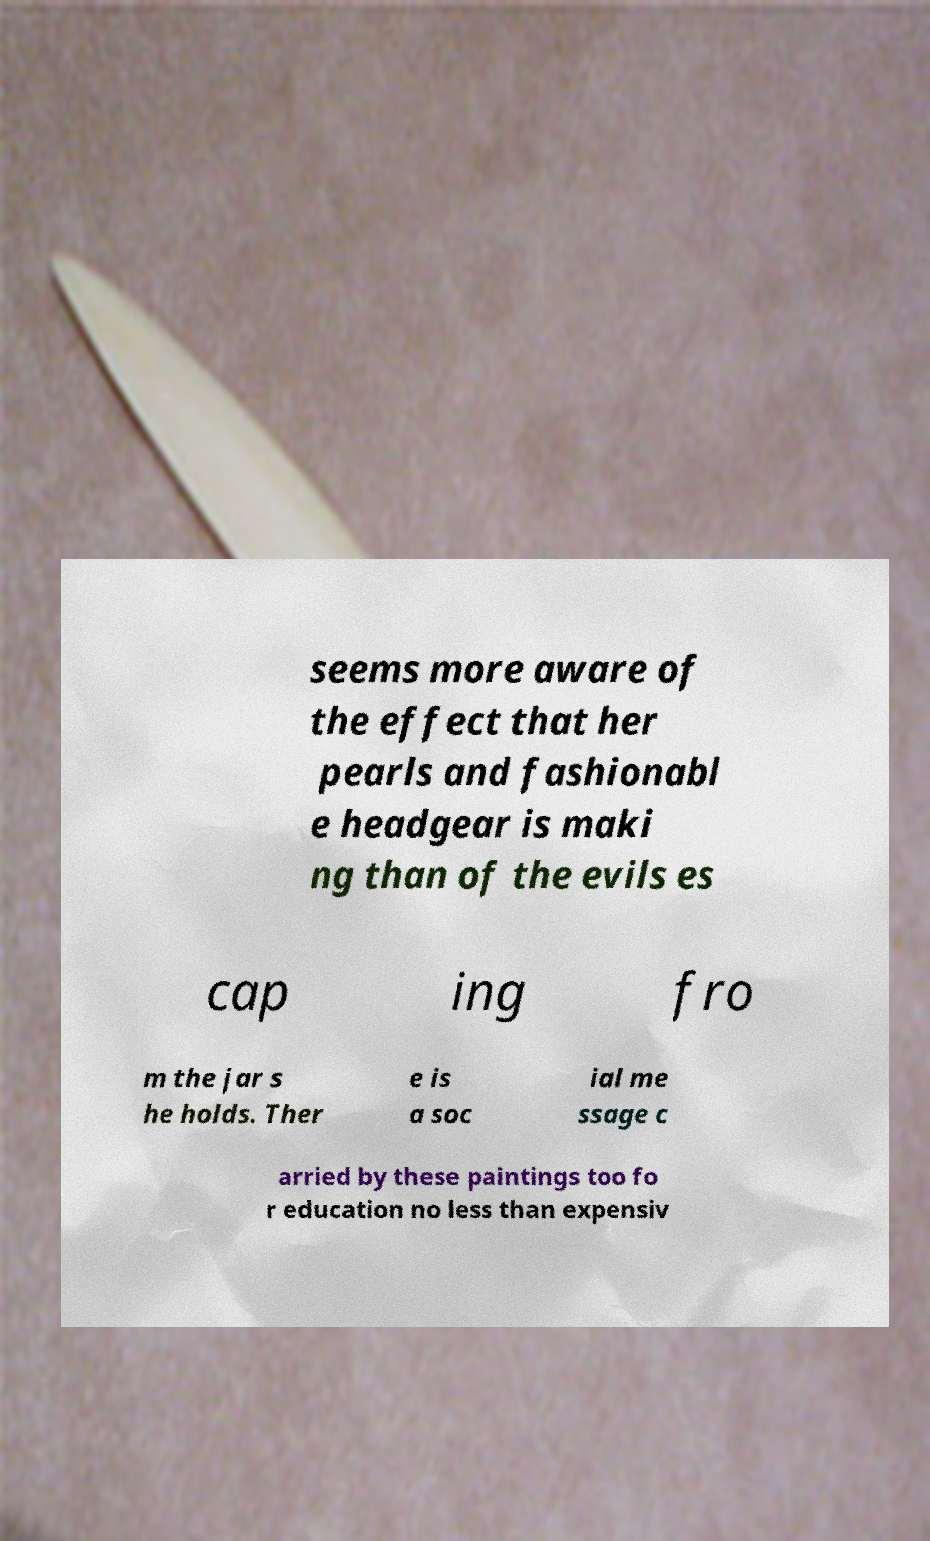There's text embedded in this image that I need extracted. Can you transcribe it verbatim? seems more aware of the effect that her pearls and fashionabl e headgear is maki ng than of the evils es cap ing fro m the jar s he holds. Ther e is a soc ial me ssage c arried by these paintings too fo r education no less than expensiv 